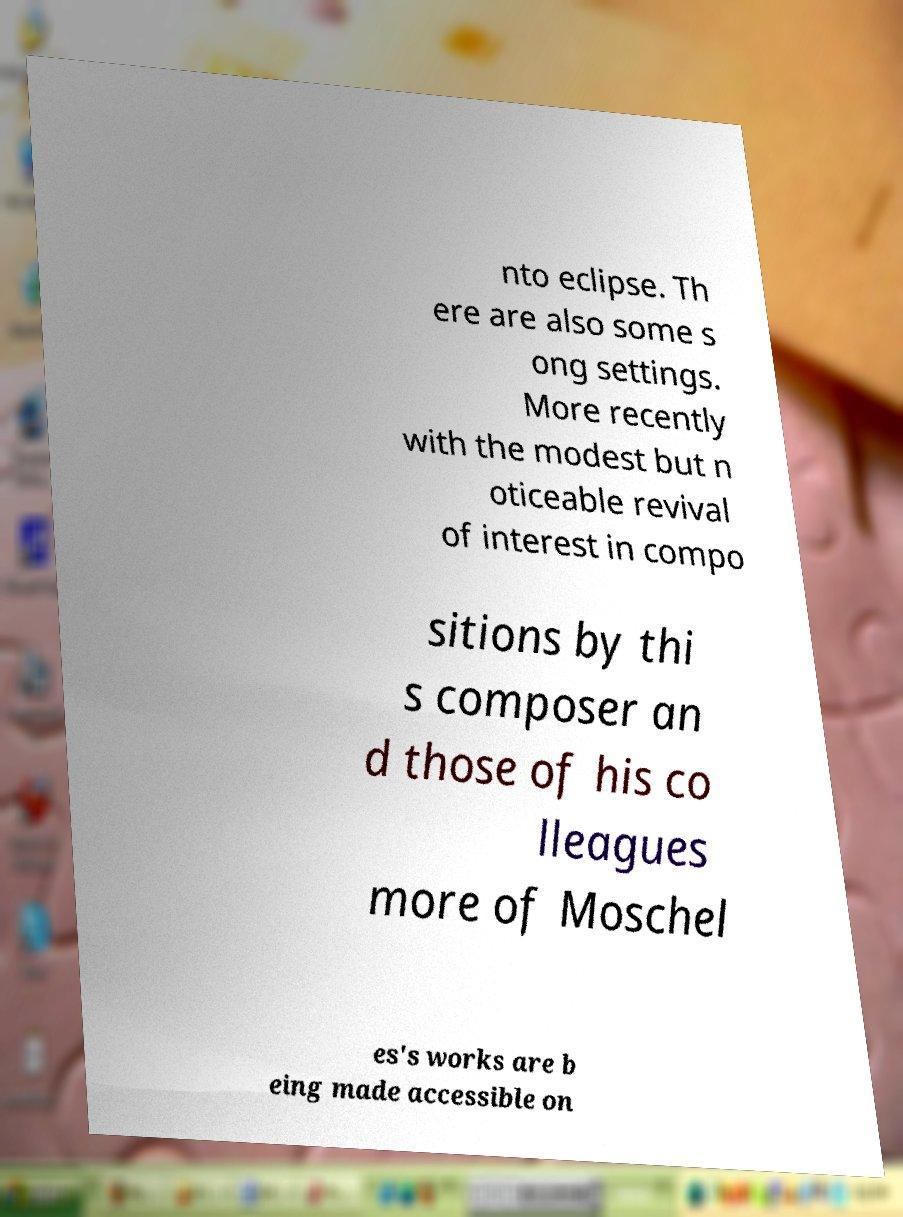I need the written content from this picture converted into text. Can you do that? nto eclipse. Th ere are also some s ong settings. More recently with the modest but n oticeable revival of interest in compo sitions by thi s composer an d those of his co lleagues more of Moschel es's works are b eing made accessible on 